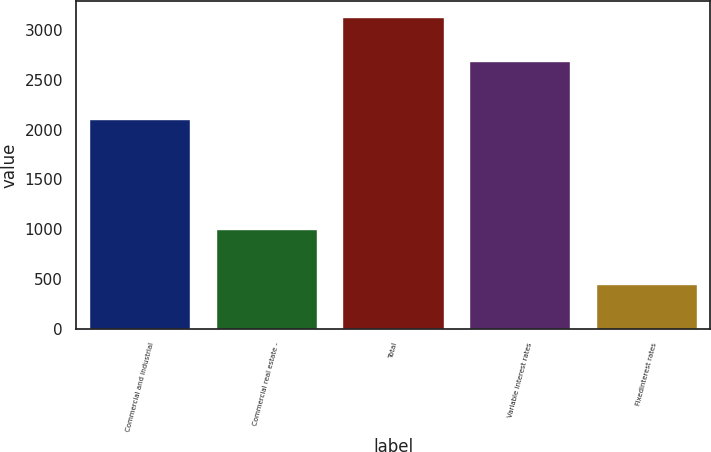<chart> <loc_0><loc_0><loc_500><loc_500><bar_chart><fcel>Commercial and industrial<fcel>Commercial real estate -<fcel>Total<fcel>Variable interest rates<fcel>Fixedinterest rates<nl><fcel>2106<fcel>1003<fcel>3131<fcel>2685<fcel>446<nl></chart> 